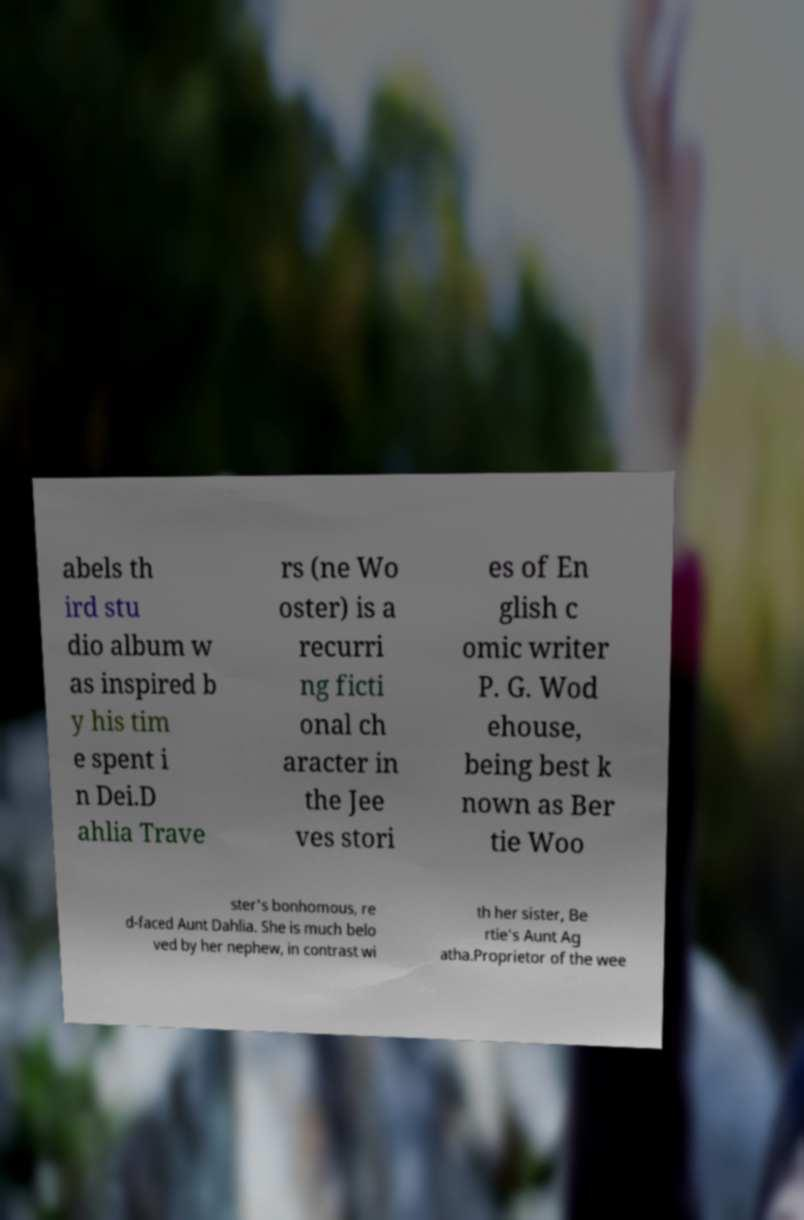Can you read and provide the text displayed in the image?This photo seems to have some interesting text. Can you extract and type it out for me? abels th ird stu dio album w as inspired b y his tim e spent i n Dei.D ahlia Trave rs (ne Wo oster) is a recurri ng ficti onal ch aracter in the Jee ves stori es of En glish c omic writer P. G. Wod ehouse, being best k nown as Ber tie Woo ster's bonhomous, re d-faced Aunt Dahlia. She is much belo ved by her nephew, in contrast wi th her sister, Be rtie's Aunt Ag atha.Proprietor of the wee 